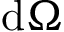Convert formula to latex. <formula><loc_0><loc_0><loc_500><loc_500>d \Omega</formula> 